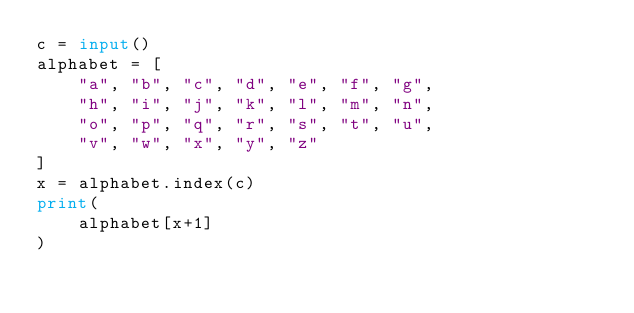<code> <loc_0><loc_0><loc_500><loc_500><_Python_>c = input()
alphabet = [
    "a", "b", "c", "d", "e", "f", "g",
    "h", "i", "j", "k", "l", "m", "n",
    "o", "p", "q", "r", "s", "t", "u",
    "v", "w", "x", "y", "z"
]
x = alphabet.index(c)
print(
    alphabet[x+1]
)
</code> 